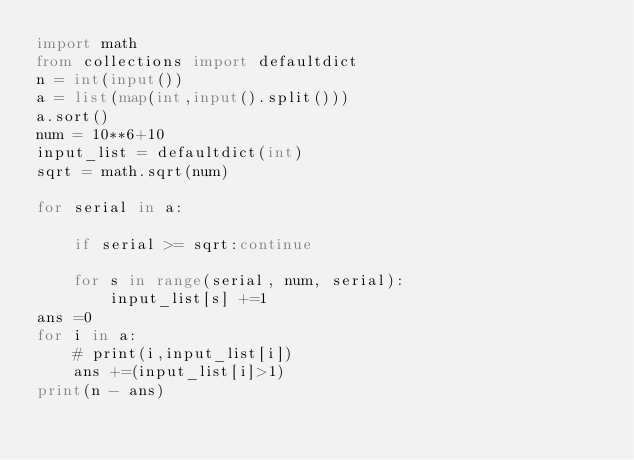<code> <loc_0><loc_0><loc_500><loc_500><_Python_>import math
from collections import defaultdict
n = int(input())
a = list(map(int,input().split()))
a.sort()
num = 10**6+10
input_list = defaultdict(int)
sqrt = math.sqrt(num)

for serial in a:

    if serial >= sqrt:continue

    for s in range(serial, num, serial): 
        input_list[s] +=1
ans =0
for i in a:
    # print(i,input_list[i])
    ans +=(input_list[i]>1)
print(n - ans)</code> 